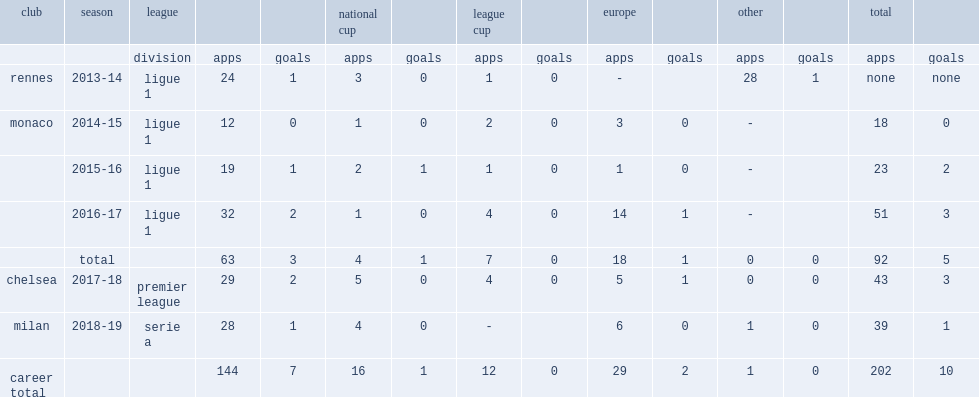Which club did bakayoko play for in 2016-17? Monaco. 